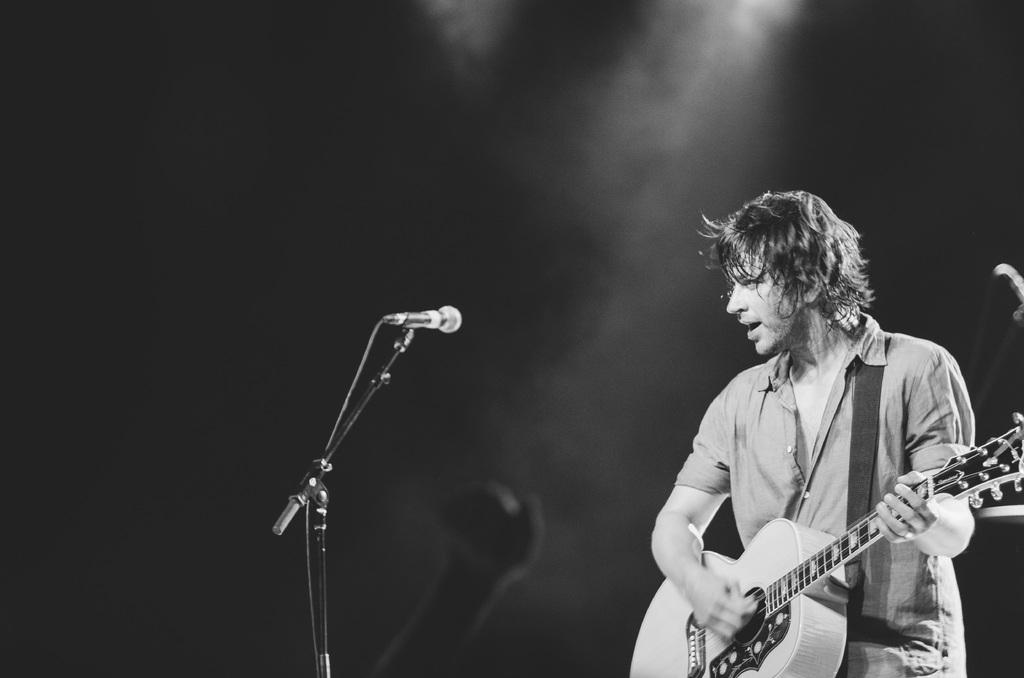What is the main object in the middle of the image? There is a microphone in the middle of the image. What is the man in the image doing? The man is playing a guitar in the bottom right side of the image. What type of quill is the man using to play the guitar in the image? There is no quill present in the image; the man is playing a guitar with his hands. 